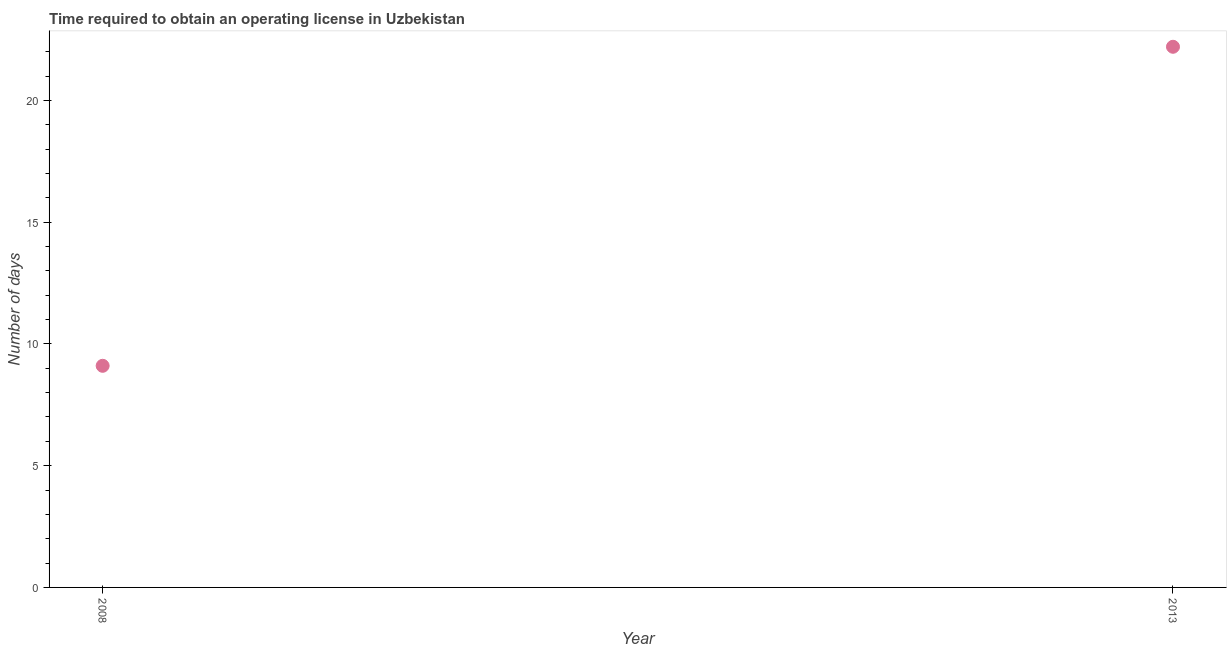What is the number of days to obtain operating license in 2008?
Ensure brevity in your answer.  9.1. Across all years, what is the maximum number of days to obtain operating license?
Provide a short and direct response. 22.2. Across all years, what is the minimum number of days to obtain operating license?
Offer a terse response. 9.1. In which year was the number of days to obtain operating license maximum?
Give a very brief answer. 2013. In which year was the number of days to obtain operating license minimum?
Give a very brief answer. 2008. What is the sum of the number of days to obtain operating license?
Offer a very short reply. 31.3. What is the difference between the number of days to obtain operating license in 2008 and 2013?
Keep it short and to the point. -13.1. What is the average number of days to obtain operating license per year?
Provide a short and direct response. 15.65. What is the median number of days to obtain operating license?
Provide a succinct answer. 15.65. Do a majority of the years between 2013 and 2008 (inclusive) have number of days to obtain operating license greater than 11 days?
Ensure brevity in your answer.  No. What is the ratio of the number of days to obtain operating license in 2008 to that in 2013?
Ensure brevity in your answer.  0.41. Does the number of days to obtain operating license monotonically increase over the years?
Make the answer very short. Yes. How many years are there in the graph?
Offer a very short reply. 2. What is the difference between two consecutive major ticks on the Y-axis?
Make the answer very short. 5. What is the title of the graph?
Your answer should be compact. Time required to obtain an operating license in Uzbekistan. What is the label or title of the Y-axis?
Offer a very short reply. Number of days. What is the Number of days in 2008?
Your answer should be very brief. 9.1. What is the Number of days in 2013?
Your answer should be compact. 22.2. What is the difference between the Number of days in 2008 and 2013?
Keep it short and to the point. -13.1. What is the ratio of the Number of days in 2008 to that in 2013?
Ensure brevity in your answer.  0.41. 